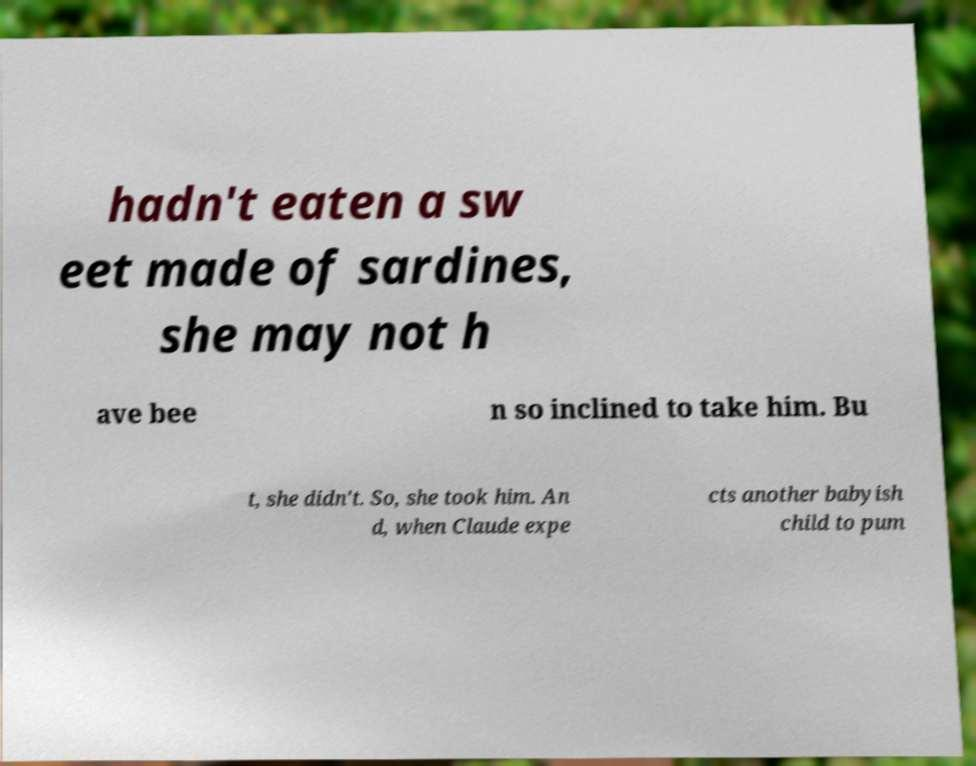Please read and relay the text visible in this image. What does it say? hadn't eaten a sw eet made of sardines, she may not h ave bee n so inclined to take him. Bu t, she didn't. So, she took him. An d, when Claude expe cts another babyish child to pum 